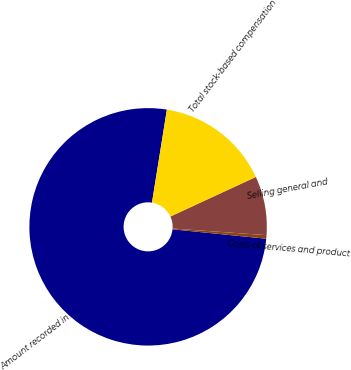Convert chart to OTSL. <chart><loc_0><loc_0><loc_500><loc_500><pie_chart><fcel>Amount recorded in<fcel>Costs of services and product<fcel>Selling general and<fcel>Total stock-based compensation<nl><fcel>75.93%<fcel>0.48%<fcel>8.02%<fcel>15.57%<nl></chart> 